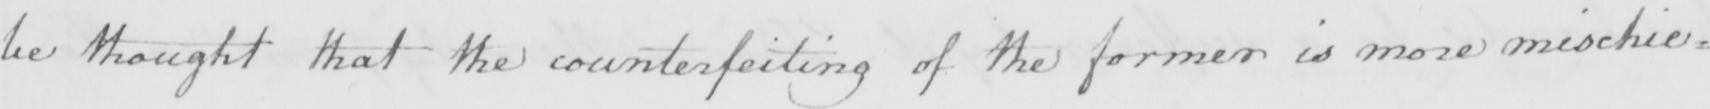Can you read and transcribe this handwriting? be thought that the counterfeiting of the former is more mischie= 